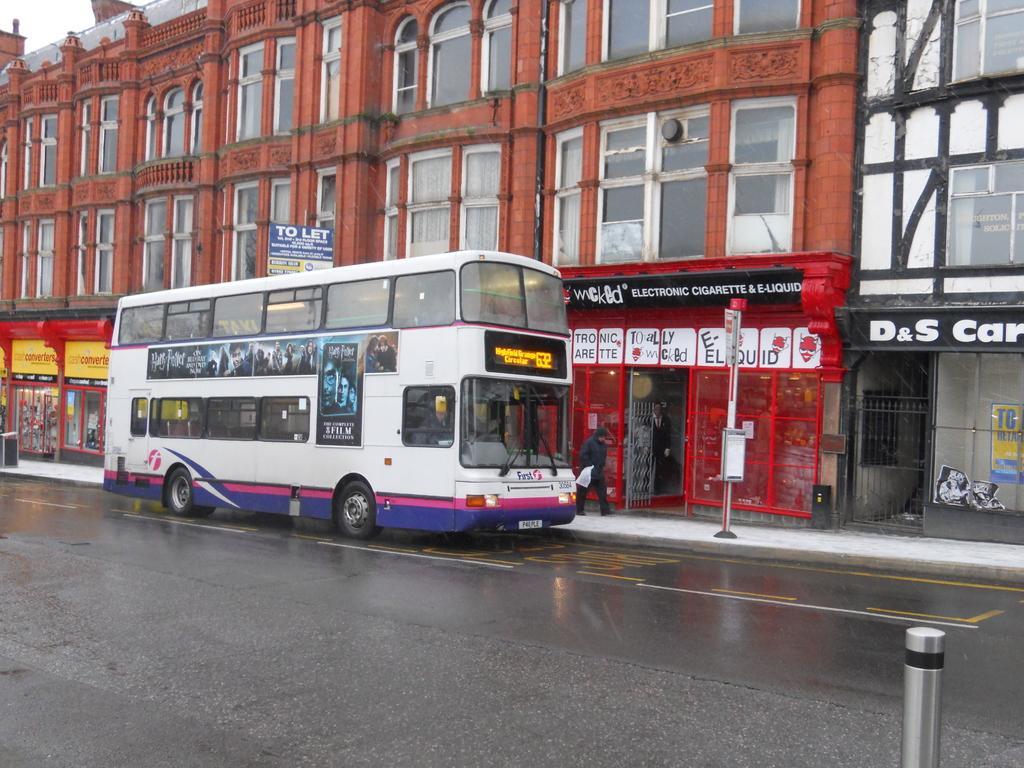Could you give a brief overview of what you see in this image? In the center of the image we can see a bus on the road and we can see a person walking. There is a sign board. In the background there are buildings and sky. At the bottom there is a road. 